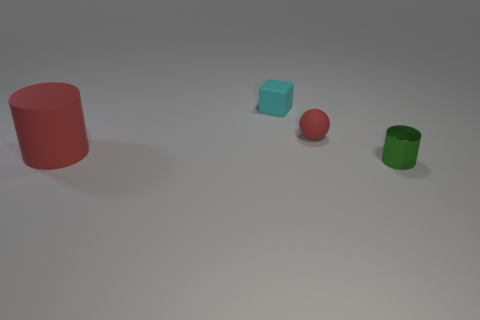Subtract all balls. How many objects are left? 3 Subtract all red cylinders. How many cylinders are left? 1 Add 1 small green metallic things. How many small green metallic things are left? 2 Add 3 purple metallic cubes. How many purple metallic cubes exist? 3 Add 2 big green metal cubes. How many objects exist? 6 Subtract 0 purple cubes. How many objects are left? 4 Subtract 1 cylinders. How many cylinders are left? 1 Subtract all cyan cylinders. Subtract all purple blocks. How many cylinders are left? 2 Subtract all green blocks. How many red cylinders are left? 1 Subtract all small cylinders. Subtract all small green shiny balls. How many objects are left? 3 